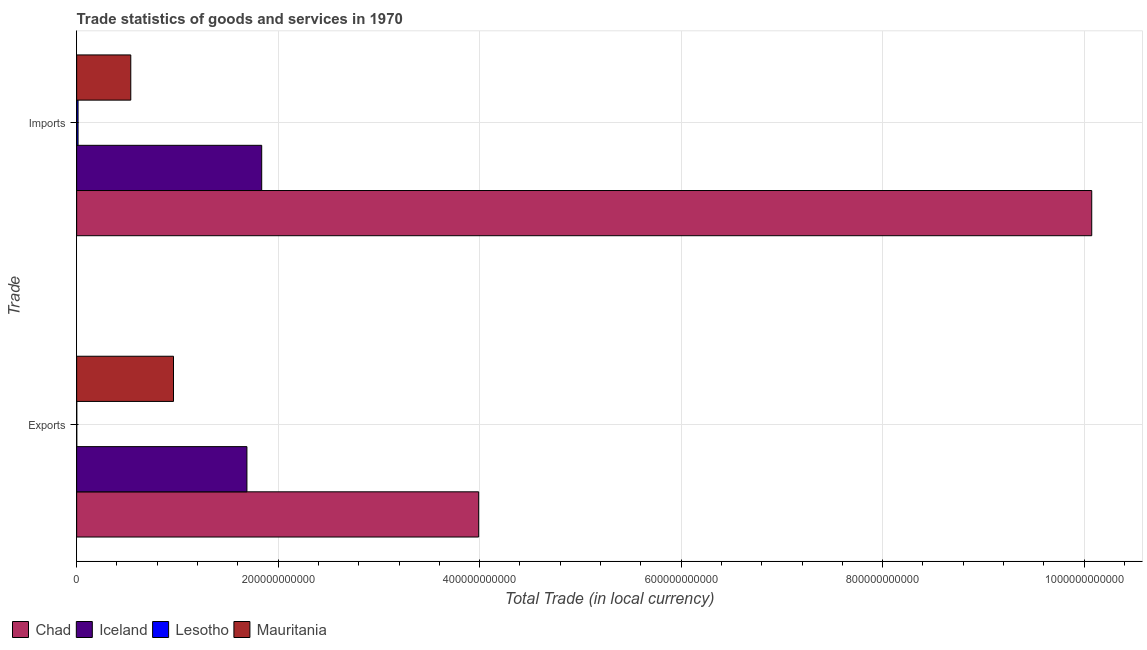Are the number of bars per tick equal to the number of legend labels?
Provide a short and direct response. Yes. How many bars are there on the 1st tick from the bottom?
Your answer should be very brief. 4. What is the label of the 1st group of bars from the top?
Offer a terse response. Imports. What is the imports of goods and services in Mauritania?
Give a very brief answer. 5.37e+1. Across all countries, what is the maximum imports of goods and services?
Keep it short and to the point. 1.01e+12. Across all countries, what is the minimum imports of goods and services?
Give a very brief answer. 1.39e+09. In which country was the export of goods and services maximum?
Your answer should be compact. Chad. In which country was the imports of goods and services minimum?
Provide a succinct answer. Lesotho. What is the total export of goods and services in the graph?
Offer a very short reply. 6.64e+11. What is the difference between the export of goods and services in Lesotho and that in Mauritania?
Make the answer very short. -9.60e+1. What is the difference between the export of goods and services in Iceland and the imports of goods and services in Mauritania?
Your answer should be compact. 1.15e+11. What is the average export of goods and services per country?
Ensure brevity in your answer.  1.66e+11. What is the difference between the export of goods and services and imports of goods and services in Iceland?
Offer a very short reply. -1.47e+1. In how many countries, is the imports of goods and services greater than 360000000000 LCU?
Offer a terse response. 1. What is the ratio of the export of goods and services in Iceland to that in Chad?
Your answer should be very brief. 0.42. In how many countries, is the export of goods and services greater than the average export of goods and services taken over all countries?
Provide a succinct answer. 2. What does the 2nd bar from the top in Imports represents?
Offer a terse response. Lesotho. What does the 1st bar from the bottom in Exports represents?
Provide a short and direct response. Chad. How many bars are there?
Give a very brief answer. 8. What is the difference between two consecutive major ticks on the X-axis?
Give a very brief answer. 2.00e+11. Are the values on the major ticks of X-axis written in scientific E-notation?
Offer a terse response. No. How many legend labels are there?
Keep it short and to the point. 4. What is the title of the graph?
Ensure brevity in your answer.  Trade statistics of goods and services in 1970. Does "South Africa" appear as one of the legend labels in the graph?
Your answer should be compact. No. What is the label or title of the X-axis?
Offer a very short reply. Total Trade (in local currency). What is the label or title of the Y-axis?
Provide a short and direct response. Trade. What is the Total Trade (in local currency) in Chad in Exports?
Provide a succinct answer. 3.99e+11. What is the Total Trade (in local currency) of Iceland in Exports?
Give a very brief answer. 1.69e+11. What is the Total Trade (in local currency) in Lesotho in Exports?
Provide a succinct answer. 1.05e+08. What is the Total Trade (in local currency) of Mauritania in Exports?
Your answer should be compact. 9.61e+1. What is the Total Trade (in local currency) in Chad in Imports?
Offer a terse response. 1.01e+12. What is the Total Trade (in local currency) in Iceland in Imports?
Offer a terse response. 1.84e+11. What is the Total Trade (in local currency) of Lesotho in Imports?
Provide a short and direct response. 1.39e+09. What is the Total Trade (in local currency) of Mauritania in Imports?
Your response must be concise. 5.37e+1. Across all Trade, what is the maximum Total Trade (in local currency) of Chad?
Your response must be concise. 1.01e+12. Across all Trade, what is the maximum Total Trade (in local currency) in Iceland?
Offer a terse response. 1.84e+11. Across all Trade, what is the maximum Total Trade (in local currency) of Lesotho?
Your answer should be very brief. 1.39e+09. Across all Trade, what is the maximum Total Trade (in local currency) in Mauritania?
Provide a succinct answer. 9.61e+1. Across all Trade, what is the minimum Total Trade (in local currency) of Chad?
Offer a terse response. 3.99e+11. Across all Trade, what is the minimum Total Trade (in local currency) in Iceland?
Provide a short and direct response. 1.69e+11. Across all Trade, what is the minimum Total Trade (in local currency) of Lesotho?
Provide a succinct answer. 1.05e+08. Across all Trade, what is the minimum Total Trade (in local currency) in Mauritania?
Keep it short and to the point. 5.37e+1. What is the total Total Trade (in local currency) in Chad in the graph?
Your answer should be compact. 1.41e+12. What is the total Total Trade (in local currency) in Iceland in the graph?
Offer a terse response. 3.53e+11. What is the total Total Trade (in local currency) of Lesotho in the graph?
Your response must be concise. 1.50e+09. What is the total Total Trade (in local currency) of Mauritania in the graph?
Your answer should be very brief. 1.50e+11. What is the difference between the Total Trade (in local currency) in Chad in Exports and that in Imports?
Give a very brief answer. -6.09e+11. What is the difference between the Total Trade (in local currency) of Iceland in Exports and that in Imports?
Your answer should be very brief. -1.47e+1. What is the difference between the Total Trade (in local currency) in Lesotho in Exports and that in Imports?
Make the answer very short. -1.28e+09. What is the difference between the Total Trade (in local currency) in Mauritania in Exports and that in Imports?
Offer a very short reply. 4.24e+1. What is the difference between the Total Trade (in local currency) of Chad in Exports and the Total Trade (in local currency) of Iceland in Imports?
Provide a short and direct response. 2.15e+11. What is the difference between the Total Trade (in local currency) in Chad in Exports and the Total Trade (in local currency) in Lesotho in Imports?
Give a very brief answer. 3.98e+11. What is the difference between the Total Trade (in local currency) of Chad in Exports and the Total Trade (in local currency) of Mauritania in Imports?
Ensure brevity in your answer.  3.45e+11. What is the difference between the Total Trade (in local currency) of Iceland in Exports and the Total Trade (in local currency) of Lesotho in Imports?
Offer a terse response. 1.68e+11. What is the difference between the Total Trade (in local currency) of Iceland in Exports and the Total Trade (in local currency) of Mauritania in Imports?
Your response must be concise. 1.15e+11. What is the difference between the Total Trade (in local currency) in Lesotho in Exports and the Total Trade (in local currency) in Mauritania in Imports?
Keep it short and to the point. -5.36e+1. What is the average Total Trade (in local currency) of Chad per Trade?
Your response must be concise. 7.03e+11. What is the average Total Trade (in local currency) of Iceland per Trade?
Your answer should be very brief. 1.76e+11. What is the average Total Trade (in local currency) of Lesotho per Trade?
Provide a succinct answer. 7.48e+08. What is the average Total Trade (in local currency) in Mauritania per Trade?
Offer a very short reply. 7.49e+1. What is the difference between the Total Trade (in local currency) in Chad and Total Trade (in local currency) in Iceland in Exports?
Offer a terse response. 2.30e+11. What is the difference between the Total Trade (in local currency) of Chad and Total Trade (in local currency) of Lesotho in Exports?
Keep it short and to the point. 3.99e+11. What is the difference between the Total Trade (in local currency) in Chad and Total Trade (in local currency) in Mauritania in Exports?
Keep it short and to the point. 3.03e+11. What is the difference between the Total Trade (in local currency) in Iceland and Total Trade (in local currency) in Lesotho in Exports?
Ensure brevity in your answer.  1.69e+11. What is the difference between the Total Trade (in local currency) of Iceland and Total Trade (in local currency) of Mauritania in Exports?
Your response must be concise. 7.29e+1. What is the difference between the Total Trade (in local currency) of Lesotho and Total Trade (in local currency) of Mauritania in Exports?
Provide a short and direct response. -9.60e+1. What is the difference between the Total Trade (in local currency) of Chad and Total Trade (in local currency) of Iceland in Imports?
Provide a succinct answer. 8.24e+11. What is the difference between the Total Trade (in local currency) in Chad and Total Trade (in local currency) in Lesotho in Imports?
Ensure brevity in your answer.  1.01e+12. What is the difference between the Total Trade (in local currency) in Chad and Total Trade (in local currency) in Mauritania in Imports?
Your answer should be very brief. 9.54e+11. What is the difference between the Total Trade (in local currency) of Iceland and Total Trade (in local currency) of Lesotho in Imports?
Provide a succinct answer. 1.82e+11. What is the difference between the Total Trade (in local currency) of Iceland and Total Trade (in local currency) of Mauritania in Imports?
Provide a succinct answer. 1.30e+11. What is the difference between the Total Trade (in local currency) in Lesotho and Total Trade (in local currency) in Mauritania in Imports?
Provide a short and direct response. -5.23e+1. What is the ratio of the Total Trade (in local currency) of Chad in Exports to that in Imports?
Make the answer very short. 0.4. What is the ratio of the Total Trade (in local currency) in Iceland in Exports to that in Imports?
Offer a terse response. 0.92. What is the ratio of the Total Trade (in local currency) of Lesotho in Exports to that in Imports?
Give a very brief answer. 0.08. What is the ratio of the Total Trade (in local currency) in Mauritania in Exports to that in Imports?
Keep it short and to the point. 1.79. What is the difference between the highest and the second highest Total Trade (in local currency) of Chad?
Keep it short and to the point. 6.09e+11. What is the difference between the highest and the second highest Total Trade (in local currency) of Iceland?
Offer a terse response. 1.47e+1. What is the difference between the highest and the second highest Total Trade (in local currency) of Lesotho?
Make the answer very short. 1.28e+09. What is the difference between the highest and the second highest Total Trade (in local currency) of Mauritania?
Provide a succinct answer. 4.24e+1. What is the difference between the highest and the lowest Total Trade (in local currency) of Chad?
Keep it short and to the point. 6.09e+11. What is the difference between the highest and the lowest Total Trade (in local currency) in Iceland?
Make the answer very short. 1.47e+1. What is the difference between the highest and the lowest Total Trade (in local currency) of Lesotho?
Keep it short and to the point. 1.28e+09. What is the difference between the highest and the lowest Total Trade (in local currency) in Mauritania?
Offer a terse response. 4.24e+1. 